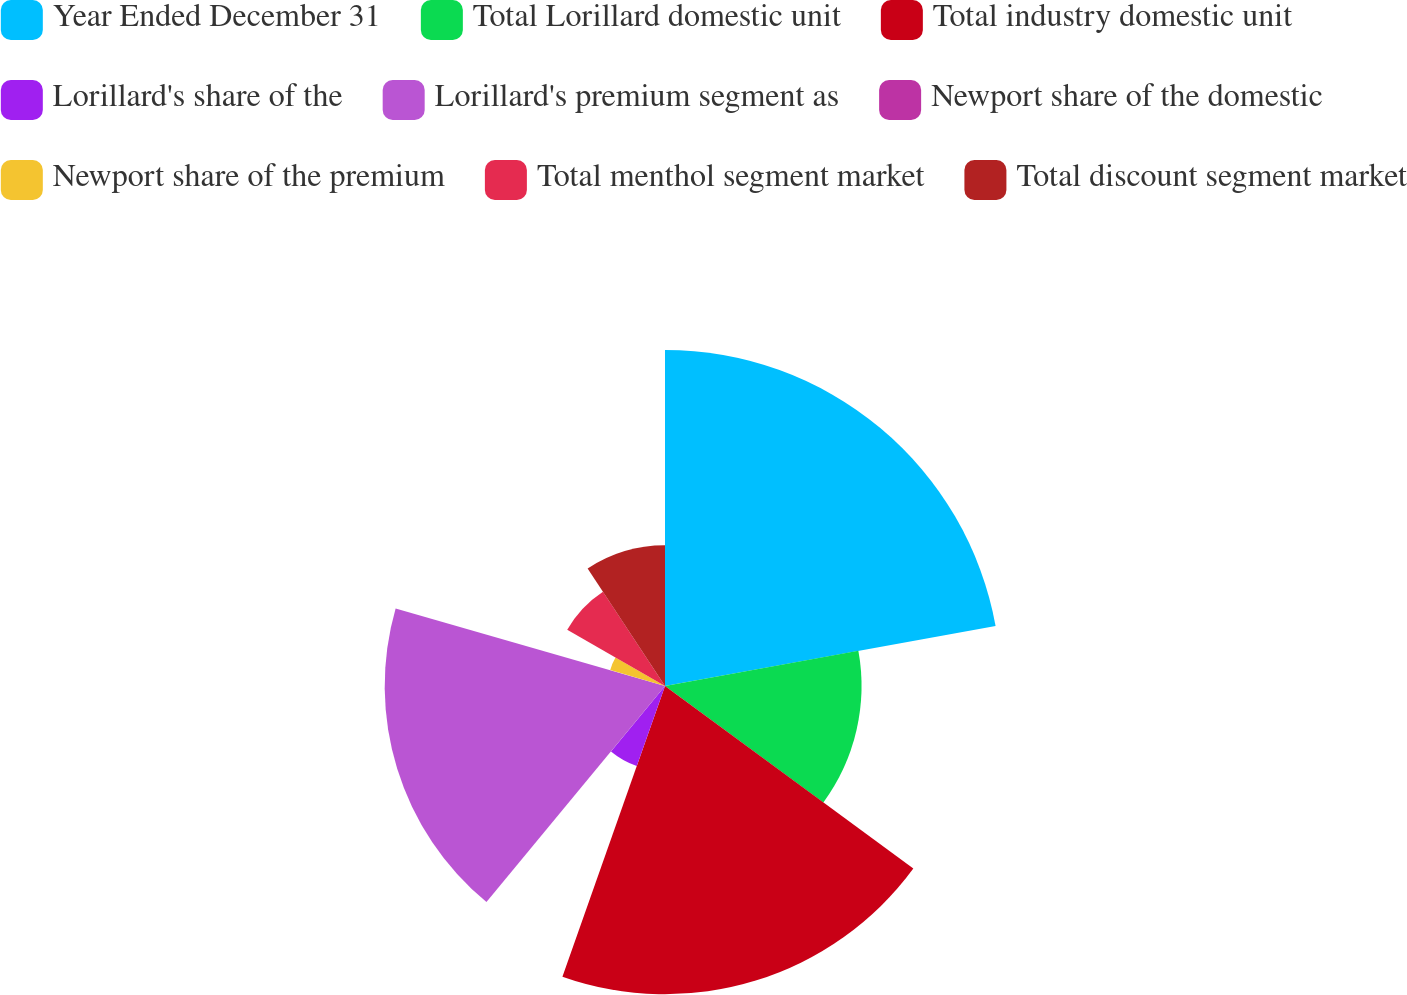<chart> <loc_0><loc_0><loc_500><loc_500><pie_chart><fcel>Year Ended December 31<fcel>Total Lorillard domestic unit<fcel>Total industry domestic unit<fcel>Lorillard's share of the<fcel>Lorillard's premium segment as<fcel>Newport share of the domestic<fcel>Newport share of the premium<fcel>Total menthol segment market<fcel>Total discount segment market<nl><fcel>22.14%<fcel>12.95%<fcel>20.31%<fcel>5.59%<fcel>18.47%<fcel>0.08%<fcel>3.76%<fcel>7.43%<fcel>9.27%<nl></chart> 